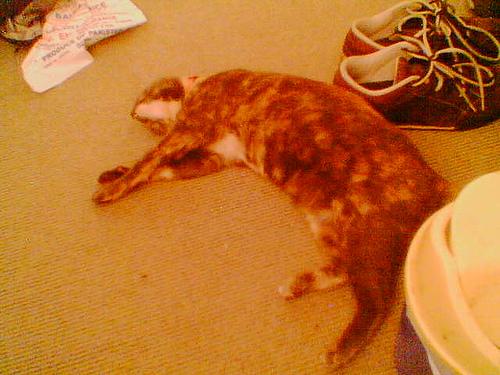Are the shoes tied?
Give a very brief answer. Yes. Do the shoes belong to the cat?
Quick response, please. No. Is the cat resting?
Write a very short answer. Yes. 